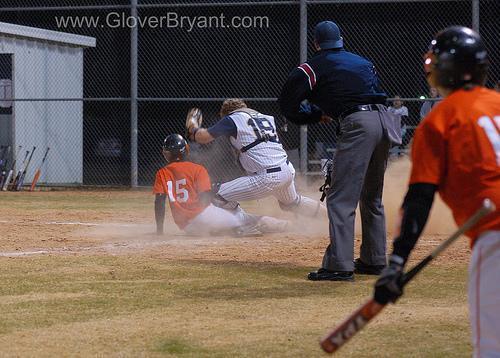How many orange team players are present in the picture?
Give a very brief answer. 2. 